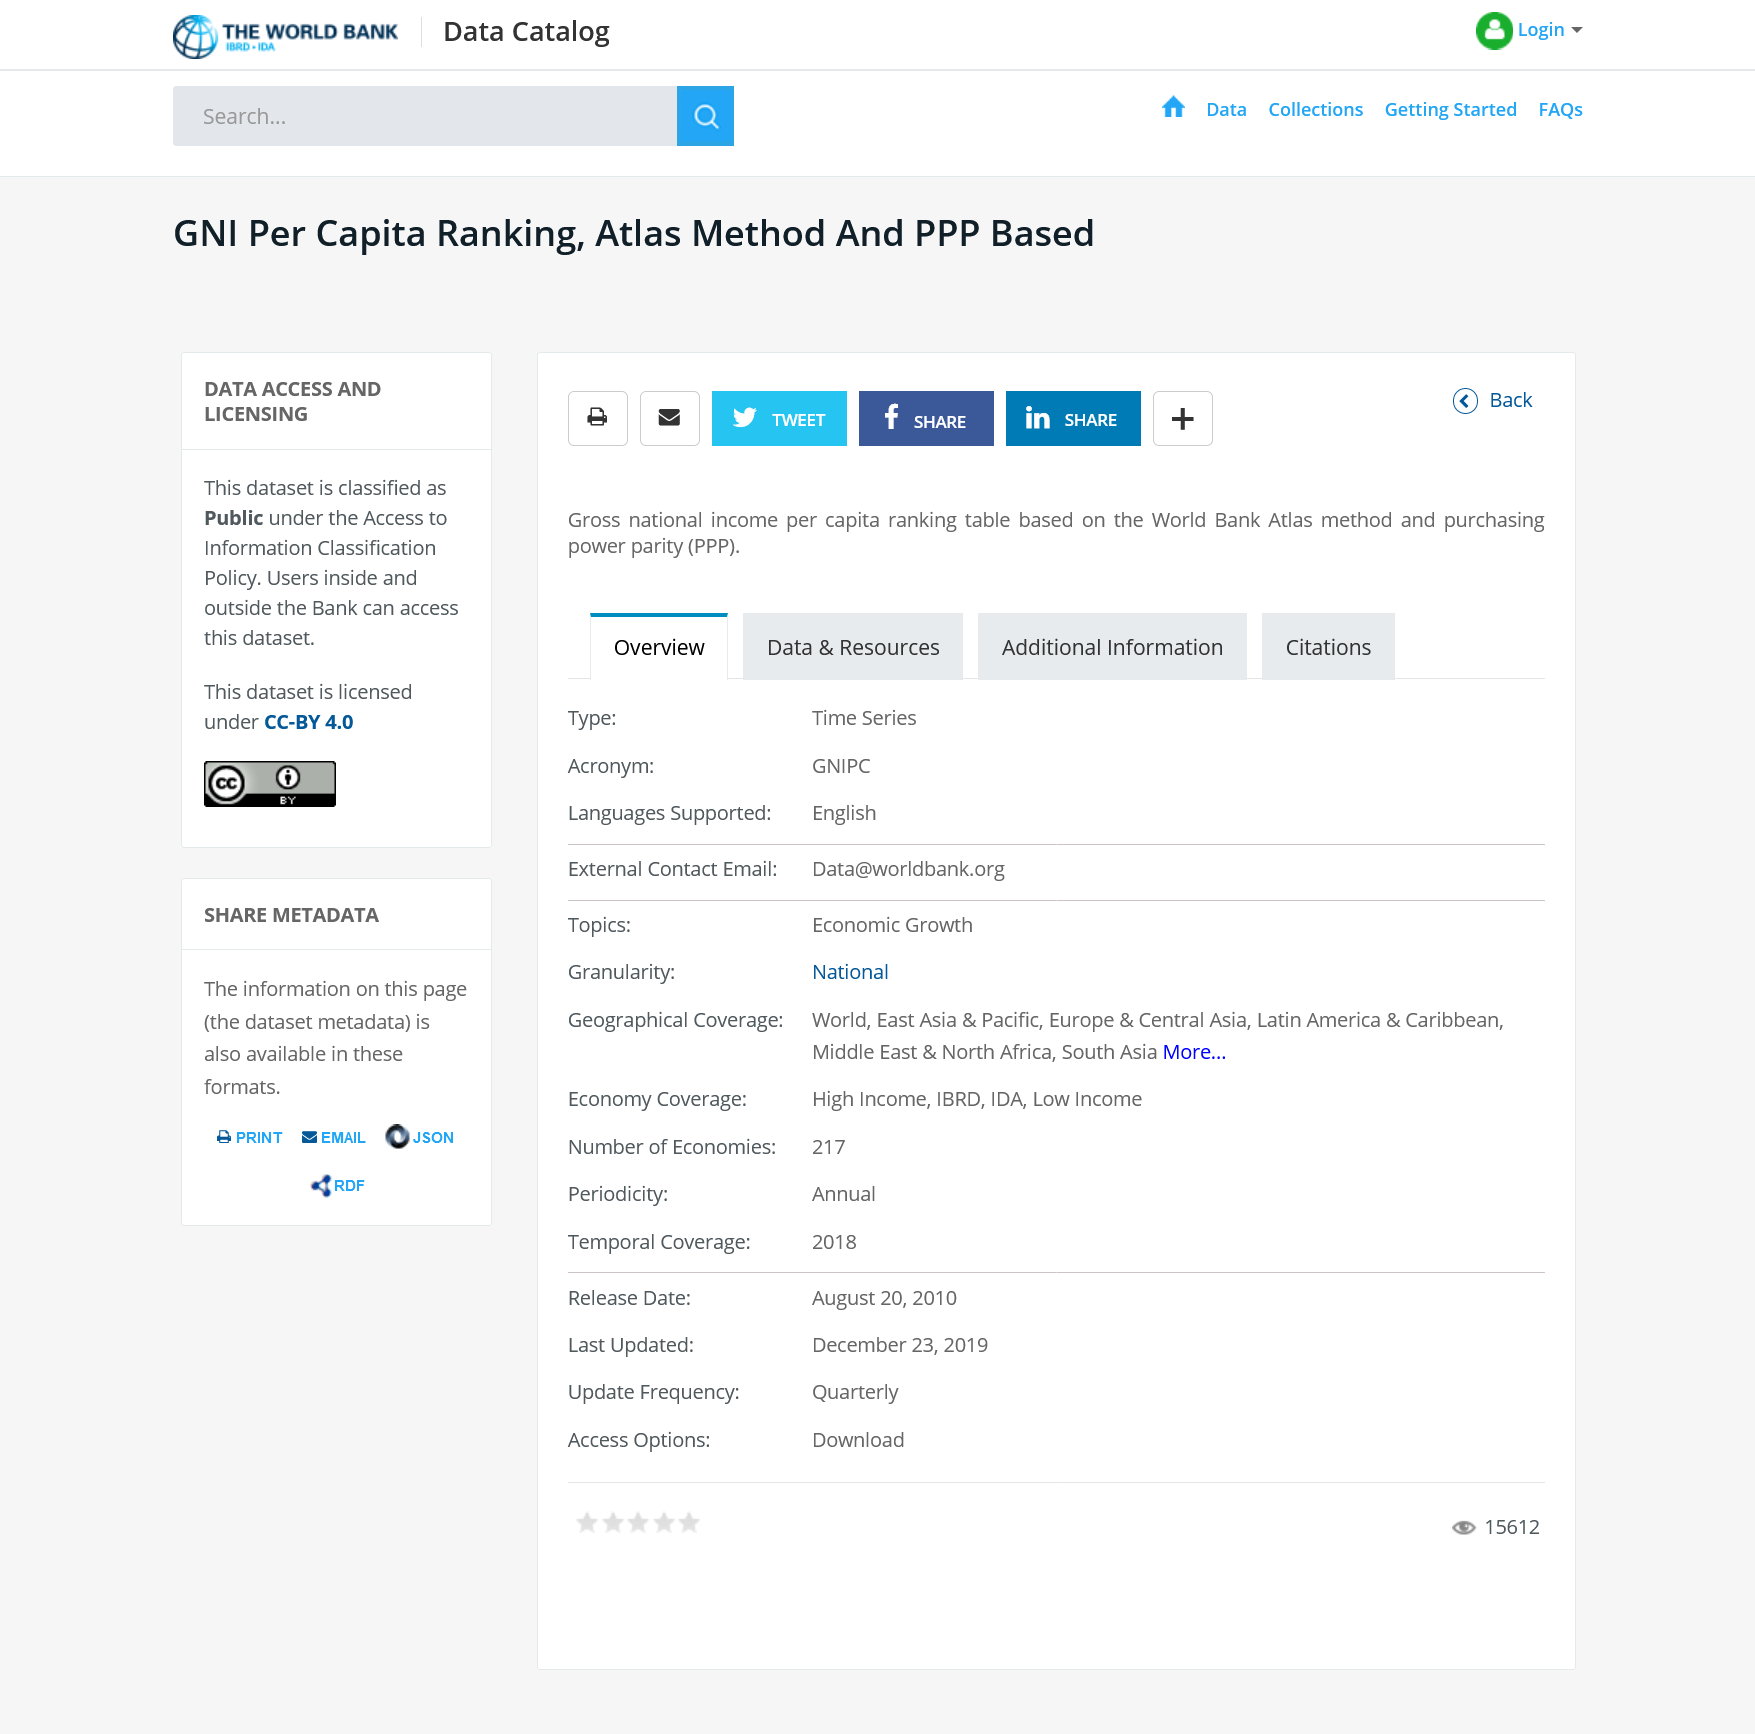List a handful of essential elements in this visual. I hereby declare that the acronym PPP stands for purchasing power parity, which is a concept used to measure the relative values of different currencies. This dataset is accessible to both Bank employees and external users. The ranking table is based on the methodology developed by the World Bank Atlas. 